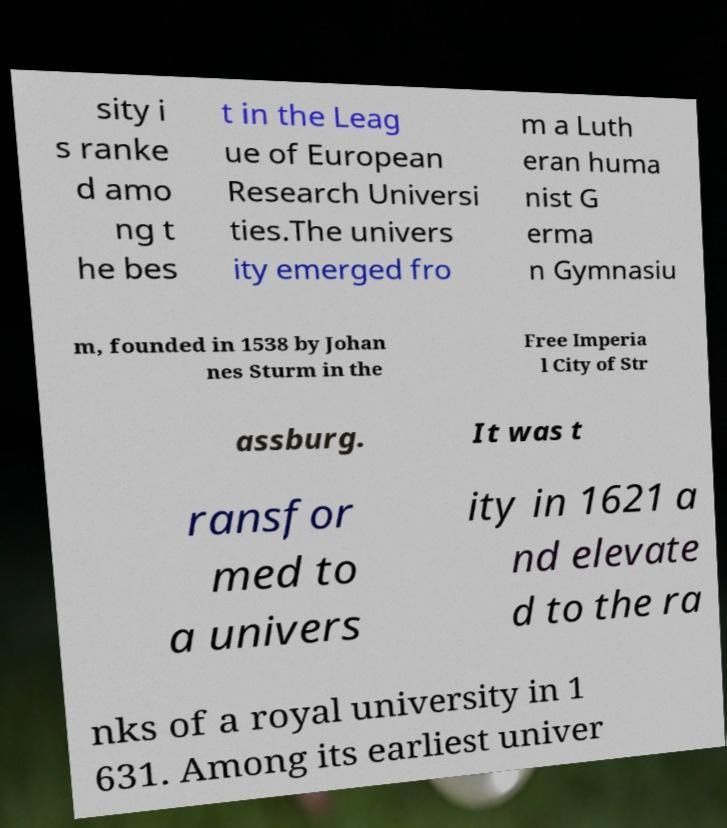I need the written content from this picture converted into text. Can you do that? sity i s ranke d amo ng t he bes t in the Leag ue of European Research Universi ties.The univers ity emerged fro m a Luth eran huma nist G erma n Gymnasiu m, founded in 1538 by Johan nes Sturm in the Free Imperia l City of Str assburg. It was t ransfor med to a univers ity in 1621 a nd elevate d to the ra nks of a royal university in 1 631. Among its earliest univer 